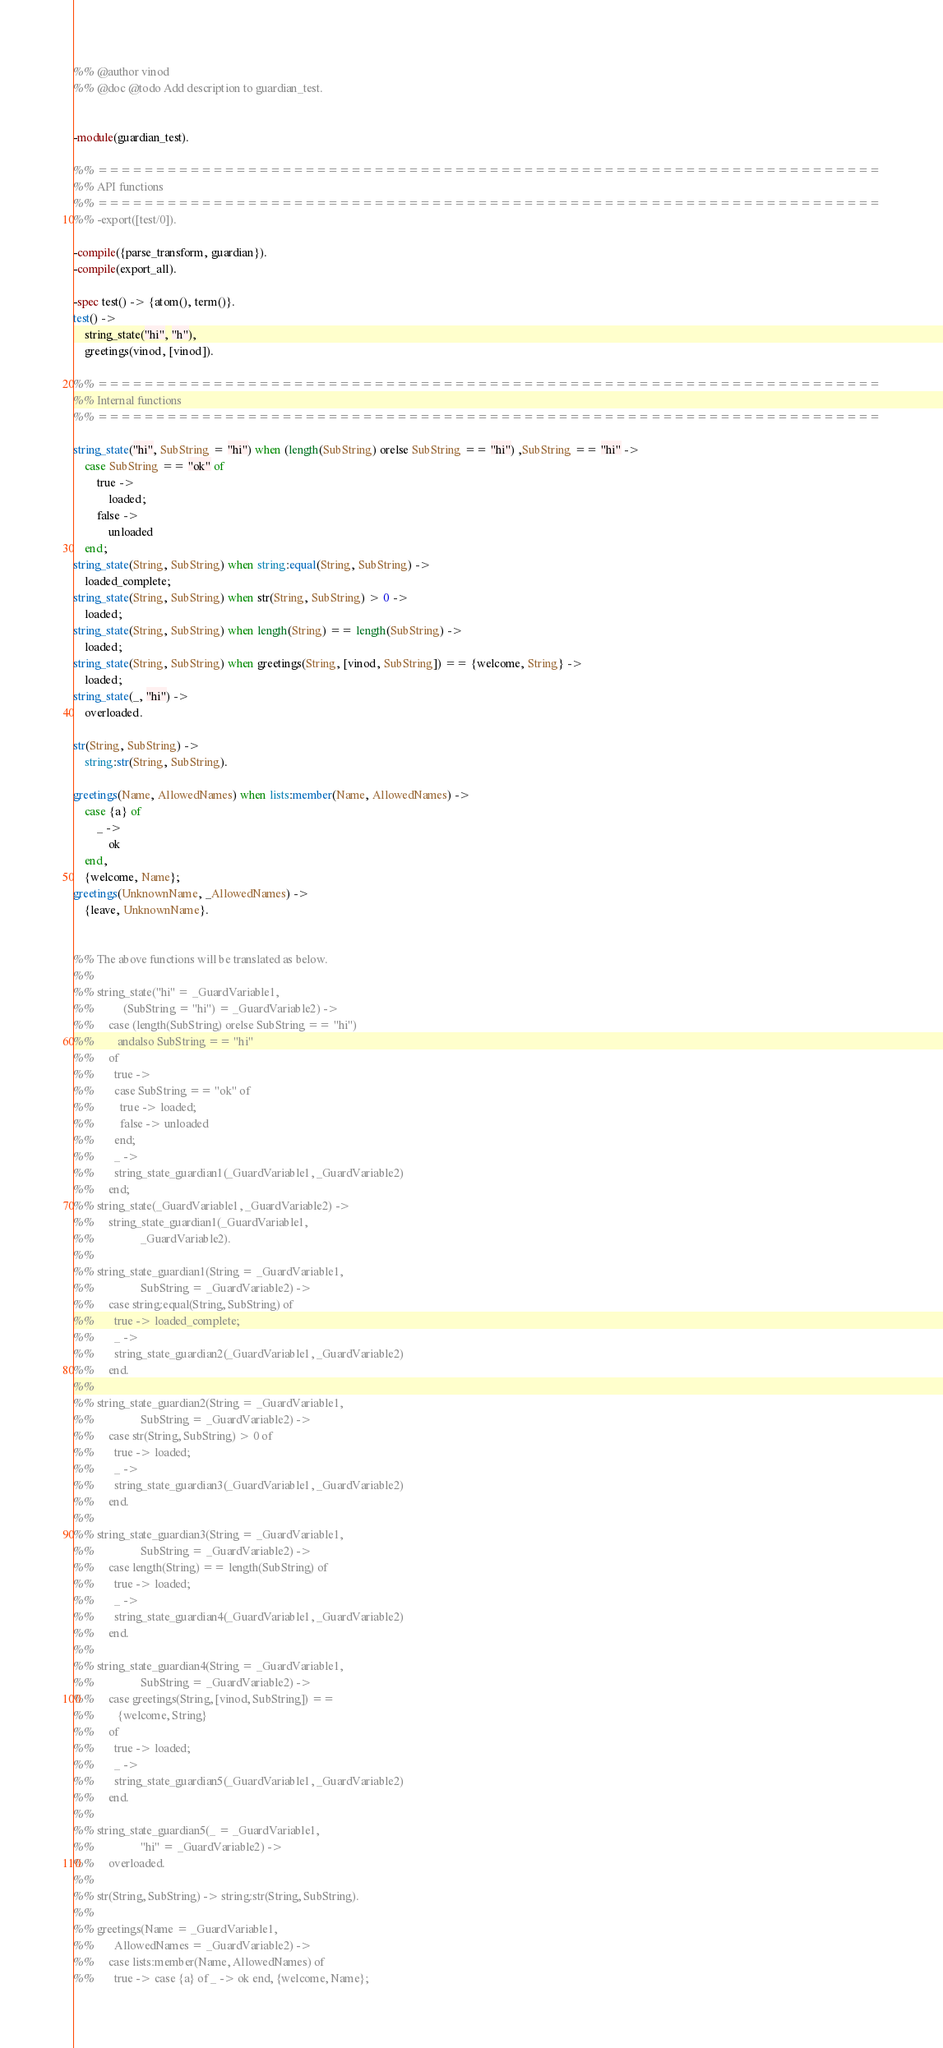Convert code to text. <code><loc_0><loc_0><loc_500><loc_500><_Erlang_>%% @author vinod
%% @doc @todo Add description to guardian_test.


-module(guardian_test).

%% ====================================================================
%% API functions
%% ====================================================================
%% -export([test/0]).

-compile({parse_transform, guardian}).
-compile(export_all).

-spec test() -> {atom(), term()}.
test() ->
    string_state("hi", "h"),
    greetings(vinod, [vinod]).

%% ====================================================================
%% Internal functions
%% ====================================================================

string_state("hi", SubString = "hi") when (length(SubString) orelse SubString == "hi") ,SubString == "hi" ->
    case SubString == "ok" of
        true ->
            loaded;
        false ->
            unloaded
    end;
string_state(String, SubString) when string:equal(String, SubString) ->
	loaded_complete;
string_state(String, SubString) when str(String, SubString) > 0 ->
	loaded;
string_state(String, SubString) when length(String) == length(SubString) ->
	loaded;
string_state(String, SubString) when greetings(String, [vinod, SubString]) == {welcome, String} ->
    loaded;
string_state(_, "hi") ->
	overloaded.

str(String, SubString) ->
	string:str(String, SubString).

greetings(Name, AllowedNames) when lists:member(Name, AllowedNames) ->
    case {a} of
        _ ->
            ok
    end,
	{welcome, Name};
greetings(UnknownName, _AllowedNames) ->
	{leave, UnknownName}.


%% The above functions will be translated as below.
%% 
%% string_state("hi" = _GuardVariable1,
%%          (SubString = "hi") = _GuardVariable2) ->
%%     case (length(SubString) orelse SubString == "hi")
%%        andalso SubString == "hi"
%%     of
%%       true ->
%%       case SubString == "ok" of
%%         true -> loaded;
%%         false -> unloaded
%%       end;
%%       _ ->
%%       string_state_guardian1(_GuardVariable1, _GuardVariable2)
%%     end;
%% string_state(_GuardVariable1, _GuardVariable2) ->
%%     string_state_guardian1(_GuardVariable1,
%%                _GuardVariable2).
%% 
%% string_state_guardian1(String = _GuardVariable1,
%%                SubString = _GuardVariable2) ->
%%     case string:equal(String, SubString) of
%%       true -> loaded_complete;
%%       _ ->
%%       string_state_guardian2(_GuardVariable1, _GuardVariable2)
%%     end.
%% 
%% string_state_guardian2(String = _GuardVariable1,
%%                SubString = _GuardVariable2) ->
%%     case str(String, SubString) > 0 of
%%       true -> loaded;
%%       _ ->
%%       string_state_guardian3(_GuardVariable1, _GuardVariable2)
%%     end.
%% 
%% string_state_guardian3(String = _GuardVariable1,
%%                SubString = _GuardVariable2) ->
%%     case length(String) == length(SubString) of
%%       true -> loaded;
%%       _ ->
%%       string_state_guardian4(_GuardVariable1, _GuardVariable2)
%%     end.
%% 
%% string_state_guardian4(String = _GuardVariable1,
%%                SubString = _GuardVariable2) ->
%%     case greetings(String, [vinod, SubString]) ==
%%        {welcome, String}
%%     of
%%       true -> loaded;
%%       _ ->
%%       string_state_guardian5(_GuardVariable1, _GuardVariable2)
%%     end.
%% 
%% string_state_guardian5(_ = _GuardVariable1,
%%                "hi" = _GuardVariable2) ->
%%     overloaded.
%% 
%% str(String, SubString) -> string:str(String, SubString).
%% 
%% greetings(Name = _GuardVariable1,
%%       AllowedNames = _GuardVariable2) ->
%%     case lists:member(Name, AllowedNames) of
%%       true -> case {a} of _ -> ok end, {welcome, Name};</code> 